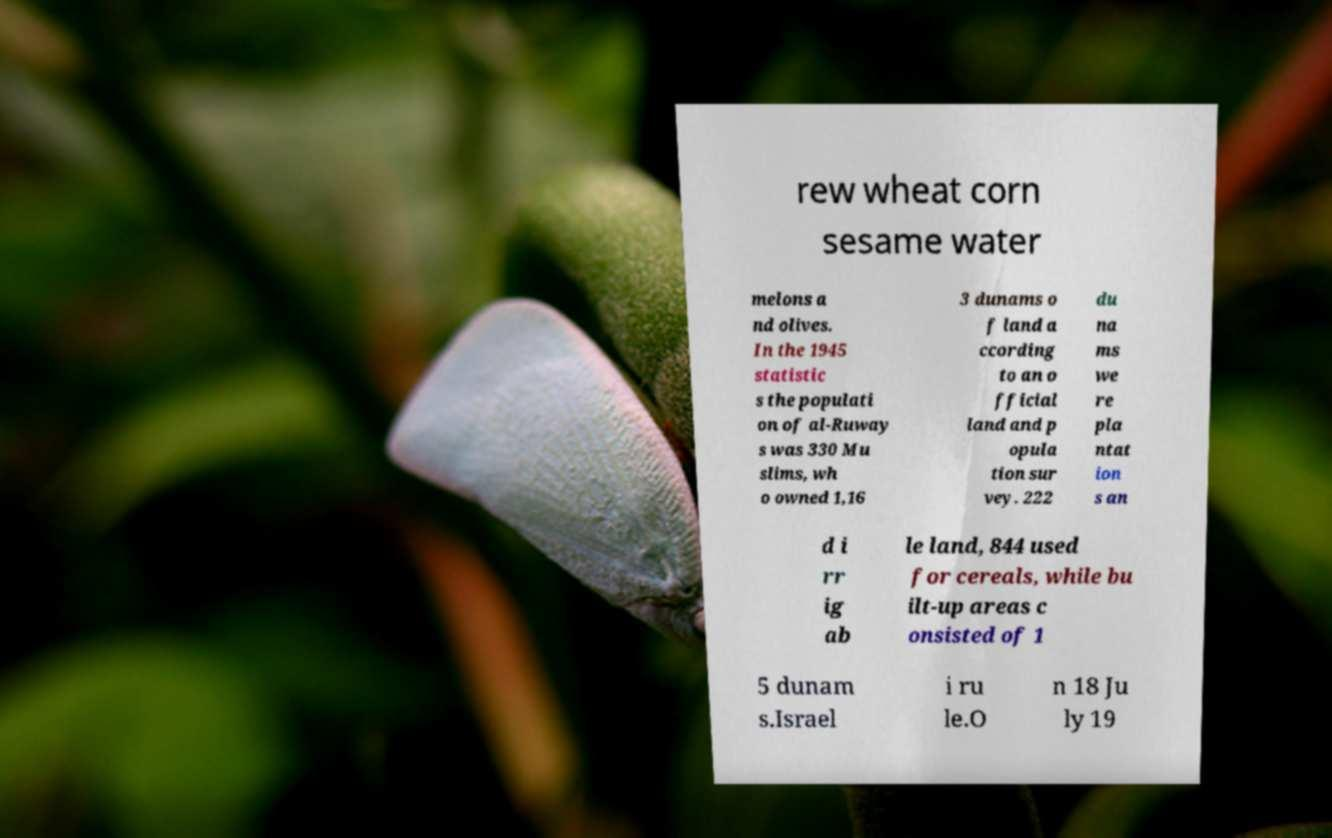For documentation purposes, I need the text within this image transcribed. Could you provide that? rew wheat corn sesame water melons a nd olives. In the 1945 statistic s the populati on of al-Ruway s was 330 Mu slims, wh o owned 1,16 3 dunams o f land a ccording to an o fficial land and p opula tion sur vey. 222 du na ms we re pla ntat ion s an d i rr ig ab le land, 844 used for cereals, while bu ilt-up areas c onsisted of 1 5 dunam s.Israel i ru le.O n 18 Ju ly 19 